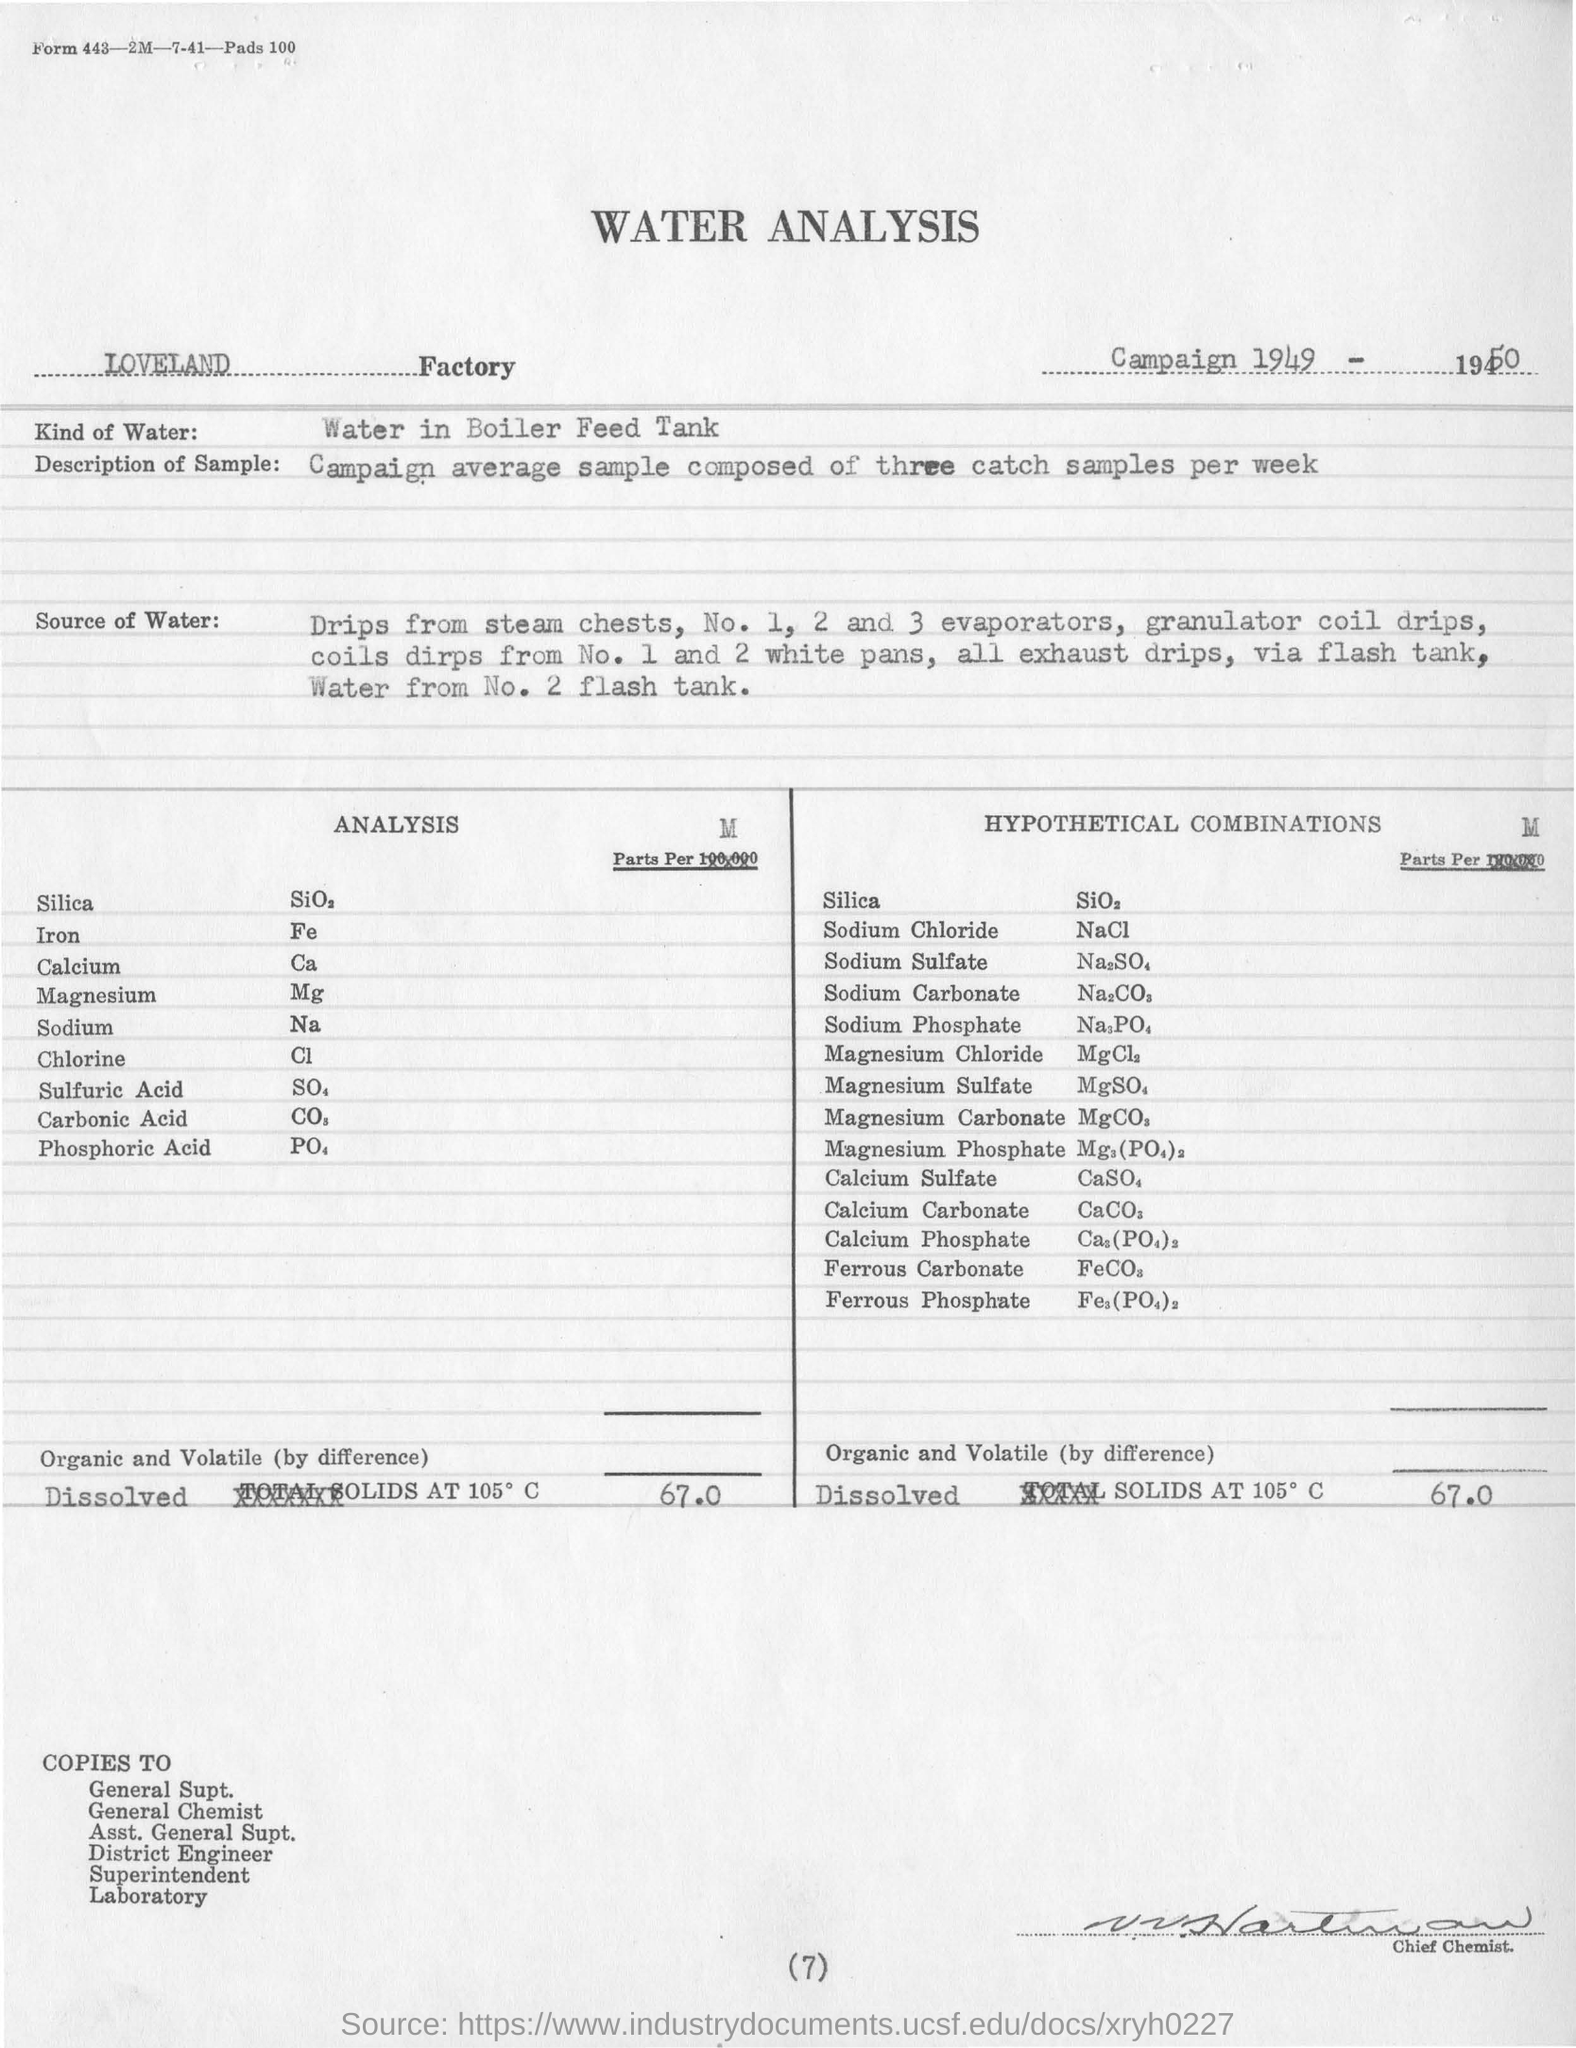Campaign average sample composed of how many catch samples per week
Provide a short and direct response. Three. What analysis does main heading mention
Give a very brief answer. WATER ANALYSIS. Which factory name was mentioned
Your answer should be very brief. LOVELAND. 